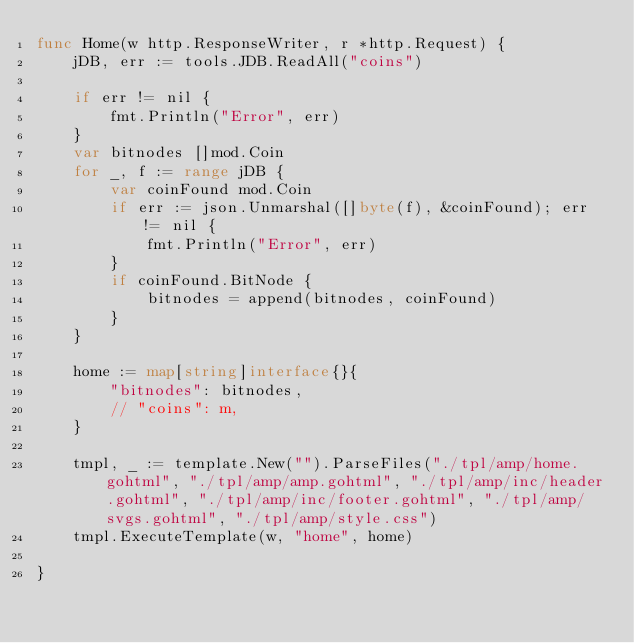<code> <loc_0><loc_0><loc_500><loc_500><_Go_>func Home(w http.ResponseWriter, r *http.Request) {
	jDB, err := tools.JDB.ReadAll("coins")

	if err != nil {
		fmt.Println("Error", err)
	}
	var bitnodes []mod.Coin
	for _, f := range jDB {
		var coinFound mod.Coin
		if err := json.Unmarshal([]byte(f), &coinFound); err != nil {
			fmt.Println("Error", err)
		}
		if coinFound.BitNode {
			bitnodes = append(bitnodes, coinFound)
		}
	}

	home := map[string]interface{}{
		"bitnodes": bitnodes,
		// "coins": m,
	}

	tmpl, _ := template.New("").ParseFiles("./tpl/amp/home.gohtml", "./tpl/amp/amp.gohtml", "./tpl/amp/inc/header.gohtml", "./tpl/amp/inc/footer.gohtml", "./tpl/amp/svgs.gohtml", "./tpl/amp/style.css")
	tmpl.ExecuteTemplate(w, "home", home)

}
</code> 